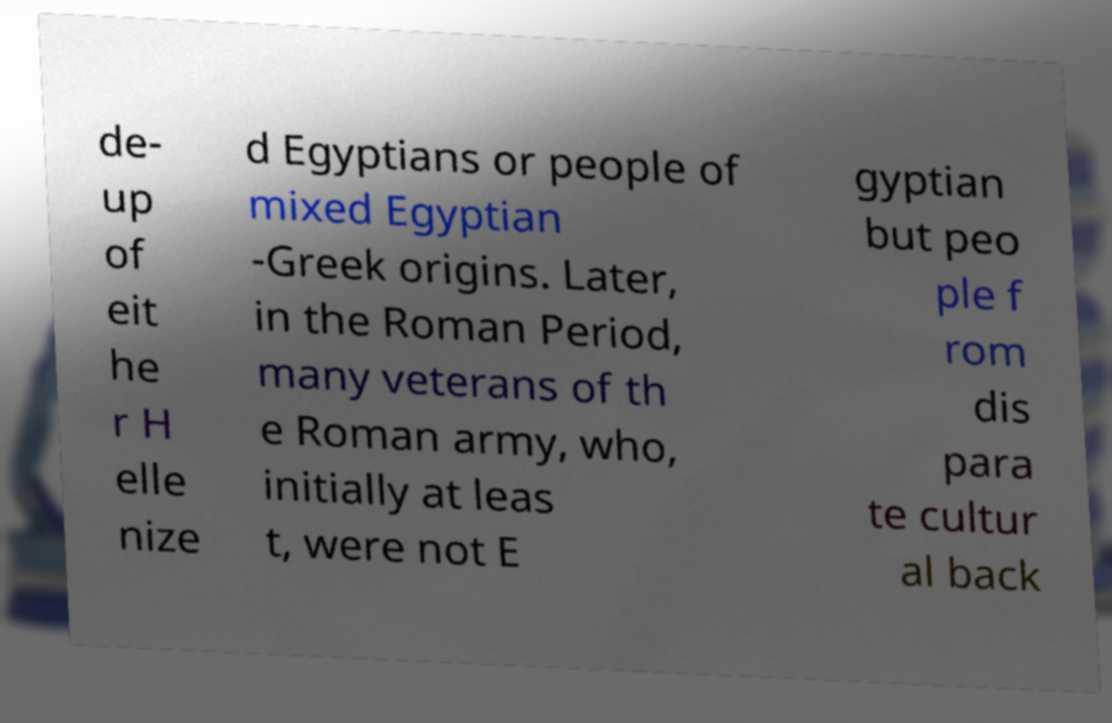Can you accurately transcribe the text from the provided image for me? de- up of eit he r H elle nize d Egyptians or people of mixed Egyptian -Greek origins. Later, in the Roman Period, many veterans of th e Roman army, who, initially at leas t, were not E gyptian but peo ple f rom dis para te cultur al back 